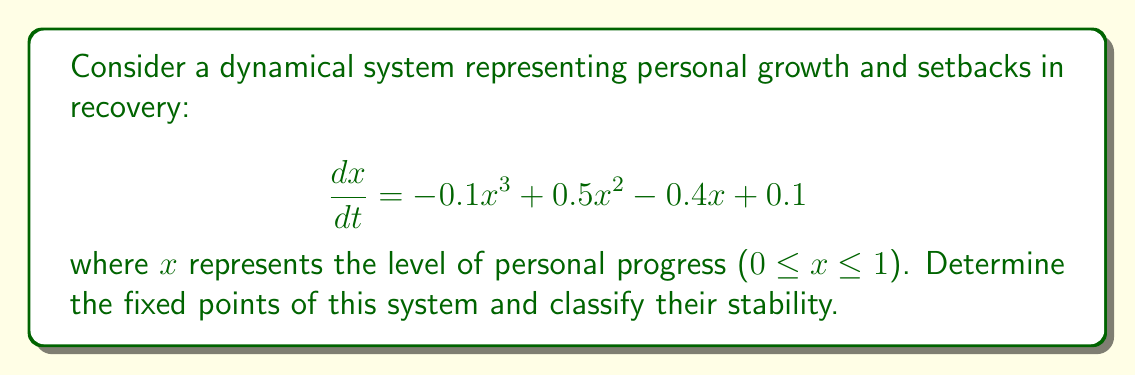Show me your answer to this math problem. 1. To find the fixed points, set $\frac{dx}{dt} = 0$:
   $$-0.1x^3 + 0.5x^2 - 0.4x + 0.1 = 0$$

2. Rearrange the equation:
   $$0.1x^3 - 0.5x^2 + 0.4x - 0.1 = 0$$

3. This is a cubic equation. We can factor out 0.1:
   $$0.1(x^3 - 5x^2 + 4x - 1) = 0$$

4. The polynomial $x^3 - 5x^2 + 4x - 1$ can be factored as $(x - 1)^2(x - 1)$:
   $$0.1(x - 1)^3 = 0$$

5. Solving this equation, we get:
   $x = 1$ (with multiplicity 3)

6. To classify stability, we find $\frac{d}{dx}(\frac{dx}{dt})$ and evaluate at $x = 1$:
   $$\frac{d}{dx}(\frac{dx}{dt}) = -0.3x^2 + x - 0.4$$
   At $x = 1$: $-0.3(1)^2 + 1 - 0.4 = 0.3$

7. Since this derivative is positive at $x = 1$, the fixed point is unstable.

This system represents a person's journey in recovery, where $x = 1$ is the desired state of full recovery. The unstable nature of this fixed point reflects the challenges of maintaining recovery, as small deviations can lead away from this state, emphasizing the ongoing effort required in the recovery process.
Answer: One unstable fixed point at $x = 1$ 